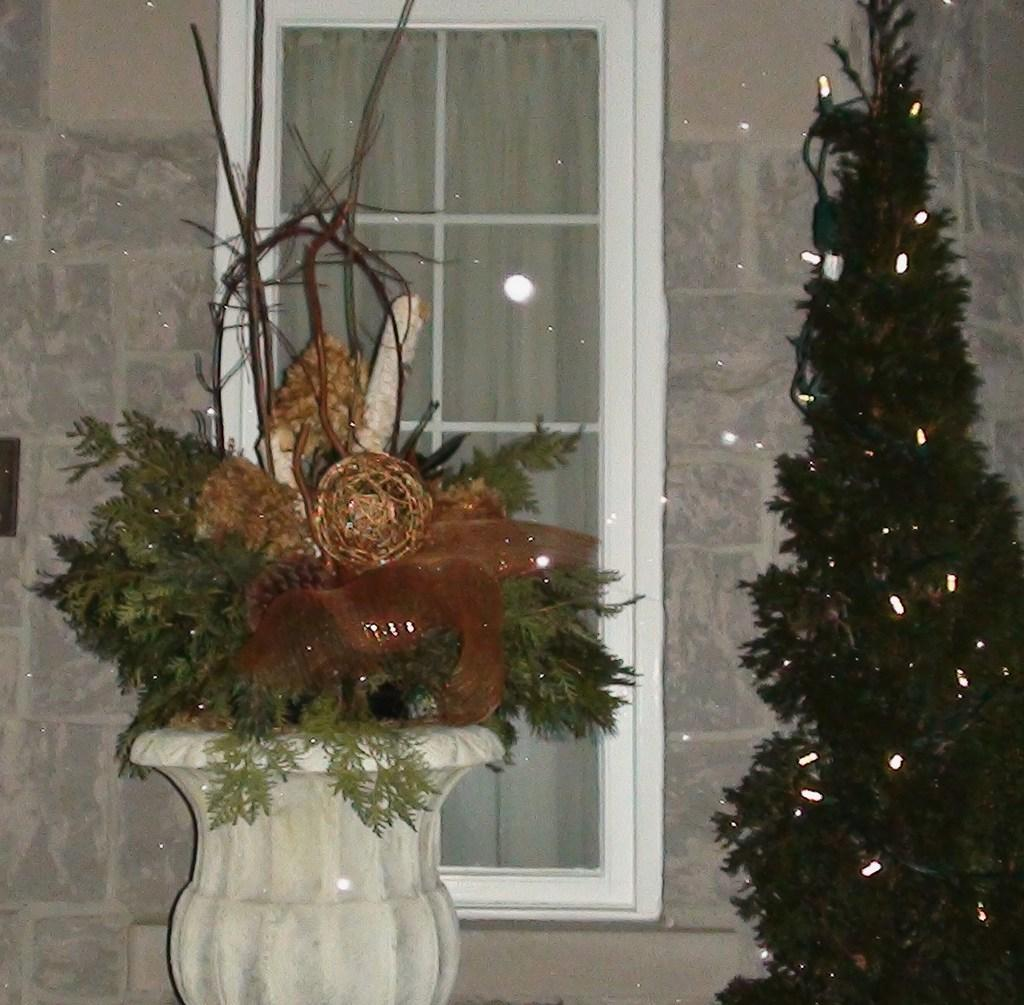What type of plant is in the image? There is a plant in the image, but its specific type is not mentioned. How is the plant contained in the image? The plant is in a pot. What other holiday decoration is visible in the image? There is a Christmas tree with lights in the image. What can be seen in the background of the image? There is a window in the background of the image. What type of window treatment is present in the image? There are curtains associated with the window. How many geese are visible in the image? There are no geese present in the image. What time of day is it in the image? The time of day is not mentioned in the image. 